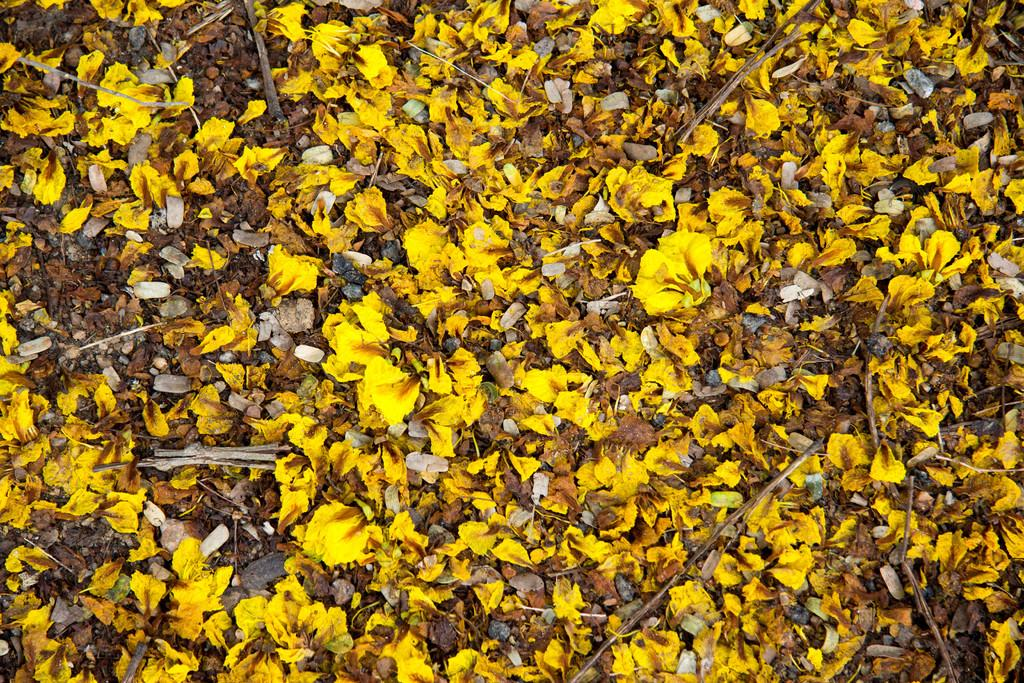What type of flowers can be seen in the image? There are yellow flowers in the image. What else can be found on the ground in the image? There are dried leaves in the image. What type of insurance is being advertised on the yellow flowers in the image? There is no insurance being advertised on the yellow flowers in the image; it is a natural scene with flowers and dried leaves. 